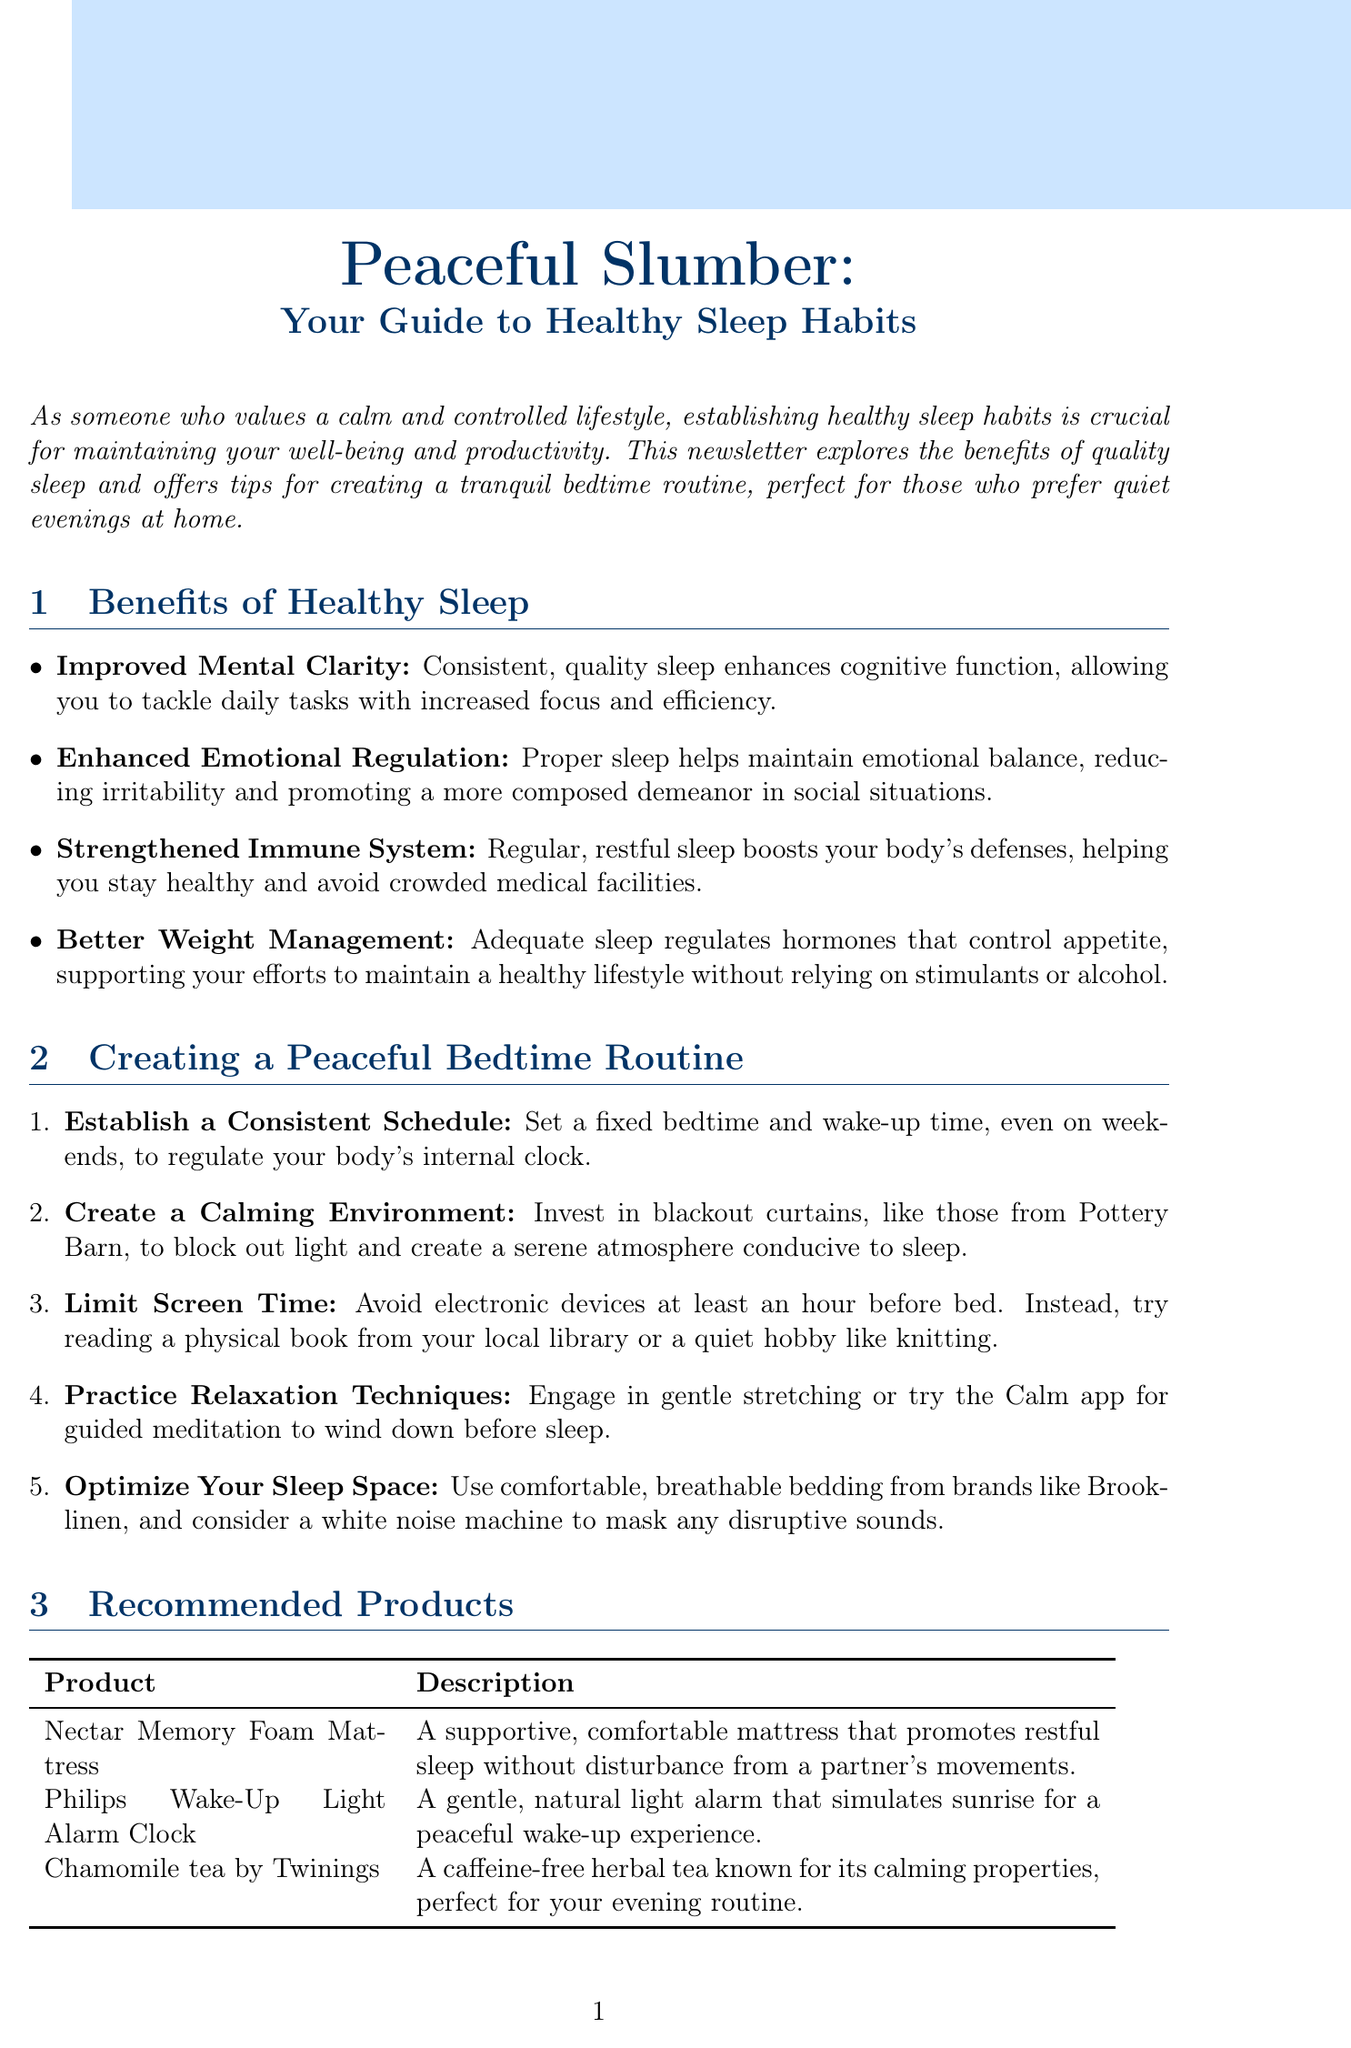What is the title of the newsletter? The title of the newsletter is stated at the top of the document under a large font.
Answer: Peaceful Slumber: Your Guide to Healthy Sleep Habits How many benefits of healthy sleep are listed? The document provides a count of the listed benefits under a specific section, enumerating them.
Answer: Four What is recommended for optimizing your sleep space? The section on creating a peaceful bedtime routine mentions specific recommendations for your sleep environment.
Answer: Comfortable, breathable bedding What product simulates sunrise for waking up? The product description lists items that promote better sleep and waking experiences, including one focused on light.
Answer: Philips Wake-Up Light Alarm Clock What is a suggested activity to limit screen time? The document advises an alternative to screen use before bed, emphasizing quiet hobbies.
Answer: Reading a physical book Which tea is mentioned for its calming properties? The product section lists items that can aid in relaxation, specifying one tea brand known for its effects.
Answer: Chamomile tea by Twinings What technique can help with relaxation before sleep? The document lists various evening practices aimed at promoting calmness for sleep, including specific activities.
Answer: Gentle stretching What should be established to regulate your internal clock? The document emphasizes the importance of maintaining a consistent routine for better sleep quality in a specific tip.
Answer: Consistent Schedule 